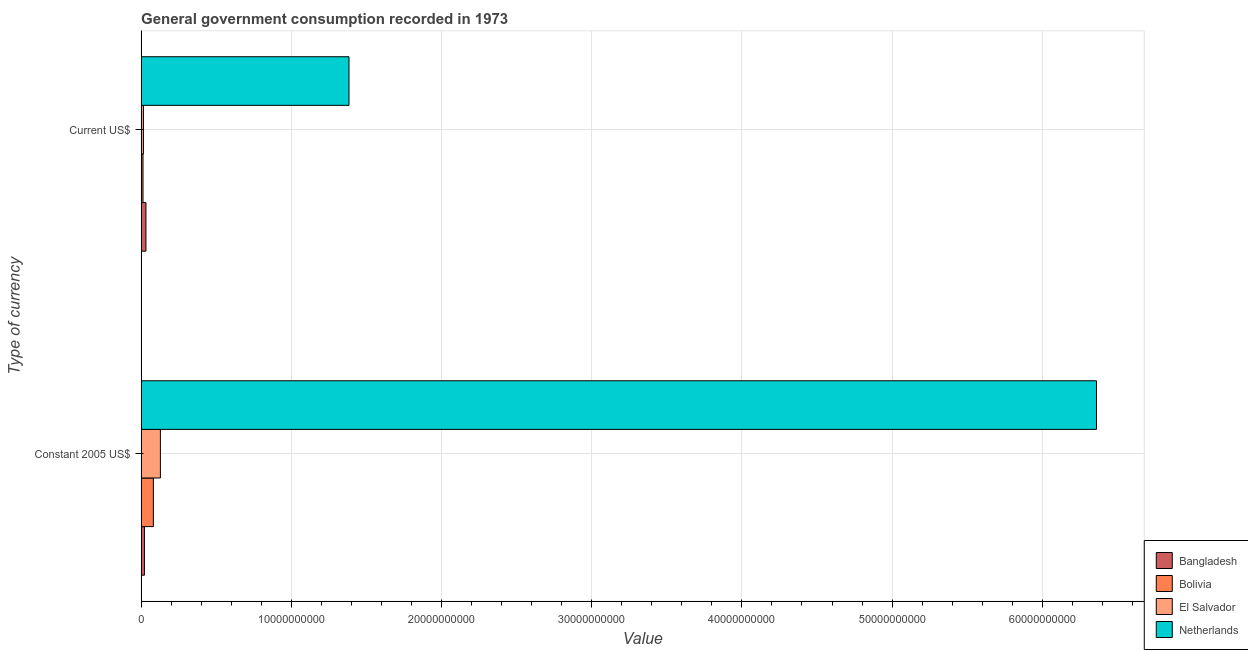How many groups of bars are there?
Ensure brevity in your answer.  2. Are the number of bars per tick equal to the number of legend labels?
Provide a short and direct response. Yes. How many bars are there on the 1st tick from the top?
Keep it short and to the point. 4. How many bars are there on the 1st tick from the bottom?
Offer a very short reply. 4. What is the label of the 2nd group of bars from the top?
Your response must be concise. Constant 2005 US$. What is the value consumed in constant 2005 us$ in Bolivia?
Make the answer very short. 8.13e+08. Across all countries, what is the maximum value consumed in constant 2005 us$?
Provide a short and direct response. 6.36e+1. Across all countries, what is the minimum value consumed in current us$?
Ensure brevity in your answer.  1.24e+08. In which country was the value consumed in constant 2005 us$ minimum?
Provide a short and direct response. Bangladesh. What is the total value consumed in constant 2005 us$ in the graph?
Make the answer very short. 6.59e+1. What is the difference between the value consumed in current us$ in Bolivia and that in Bangladesh?
Offer a terse response. -1.94e+08. What is the difference between the value consumed in current us$ in Bangladesh and the value consumed in constant 2005 us$ in Bolivia?
Offer a very short reply. -4.95e+08. What is the average value consumed in current us$ per country?
Offer a terse response. 3.61e+09. What is the difference between the value consumed in current us$ and value consumed in constant 2005 us$ in Netherlands?
Your answer should be compact. -4.98e+1. What is the ratio of the value consumed in constant 2005 us$ in Bangladesh to that in Bolivia?
Offer a terse response. 0.27. What does the 2nd bar from the top in Current US$ represents?
Offer a terse response. El Salvador. What does the 4th bar from the bottom in Constant 2005 US$ represents?
Ensure brevity in your answer.  Netherlands. What is the difference between two consecutive major ticks on the X-axis?
Offer a terse response. 1.00e+1. Are the values on the major ticks of X-axis written in scientific E-notation?
Make the answer very short. No. How many legend labels are there?
Your answer should be very brief. 4. What is the title of the graph?
Provide a short and direct response. General government consumption recorded in 1973. What is the label or title of the X-axis?
Keep it short and to the point. Value. What is the label or title of the Y-axis?
Your answer should be compact. Type of currency. What is the Value of Bangladesh in Constant 2005 US$?
Make the answer very short. 2.20e+08. What is the Value in Bolivia in Constant 2005 US$?
Ensure brevity in your answer.  8.13e+08. What is the Value in El Salvador in Constant 2005 US$?
Offer a very short reply. 1.28e+09. What is the Value of Netherlands in Constant 2005 US$?
Offer a very short reply. 6.36e+1. What is the Value of Bangladesh in Current US$?
Make the answer very short. 3.19e+08. What is the Value in Bolivia in Current US$?
Your answer should be very brief. 1.24e+08. What is the Value in El Salvador in Current US$?
Offer a very short reply. 1.51e+08. What is the Value in Netherlands in Current US$?
Offer a terse response. 1.38e+1. Across all Type of currency, what is the maximum Value in Bangladesh?
Offer a terse response. 3.19e+08. Across all Type of currency, what is the maximum Value of Bolivia?
Offer a very short reply. 8.13e+08. Across all Type of currency, what is the maximum Value of El Salvador?
Your answer should be compact. 1.28e+09. Across all Type of currency, what is the maximum Value in Netherlands?
Your answer should be very brief. 6.36e+1. Across all Type of currency, what is the minimum Value in Bangladesh?
Ensure brevity in your answer.  2.20e+08. Across all Type of currency, what is the minimum Value of Bolivia?
Your response must be concise. 1.24e+08. Across all Type of currency, what is the minimum Value in El Salvador?
Give a very brief answer. 1.51e+08. Across all Type of currency, what is the minimum Value in Netherlands?
Your answer should be compact. 1.38e+1. What is the total Value in Bangladesh in the graph?
Offer a very short reply. 5.39e+08. What is the total Value of Bolivia in the graph?
Keep it short and to the point. 9.38e+08. What is the total Value of El Salvador in the graph?
Your answer should be compact. 1.43e+09. What is the total Value in Netherlands in the graph?
Give a very brief answer. 7.74e+1. What is the difference between the Value of Bangladesh in Constant 2005 US$ and that in Current US$?
Offer a terse response. -9.83e+07. What is the difference between the Value of Bolivia in Constant 2005 US$ and that in Current US$?
Offer a terse response. 6.89e+08. What is the difference between the Value in El Salvador in Constant 2005 US$ and that in Current US$?
Give a very brief answer. 1.13e+09. What is the difference between the Value in Netherlands in Constant 2005 US$ and that in Current US$?
Keep it short and to the point. 4.98e+1. What is the difference between the Value of Bangladesh in Constant 2005 US$ and the Value of Bolivia in Current US$?
Offer a terse response. 9.58e+07. What is the difference between the Value in Bangladesh in Constant 2005 US$ and the Value in El Salvador in Current US$?
Offer a very short reply. 6.91e+07. What is the difference between the Value of Bangladesh in Constant 2005 US$ and the Value of Netherlands in Current US$?
Give a very brief answer. -1.36e+1. What is the difference between the Value of Bolivia in Constant 2005 US$ and the Value of El Salvador in Current US$?
Give a very brief answer. 6.62e+08. What is the difference between the Value in Bolivia in Constant 2005 US$ and the Value in Netherlands in Current US$?
Offer a very short reply. -1.30e+1. What is the difference between the Value in El Salvador in Constant 2005 US$ and the Value in Netherlands in Current US$?
Keep it short and to the point. -1.26e+1. What is the average Value in Bangladesh per Type of currency?
Give a very brief answer. 2.69e+08. What is the average Value of Bolivia per Type of currency?
Your response must be concise. 4.69e+08. What is the average Value in El Salvador per Type of currency?
Provide a succinct answer. 7.16e+08. What is the average Value of Netherlands per Type of currency?
Keep it short and to the point. 3.87e+1. What is the difference between the Value in Bangladesh and Value in Bolivia in Constant 2005 US$?
Give a very brief answer. -5.93e+08. What is the difference between the Value in Bangladesh and Value in El Salvador in Constant 2005 US$?
Your response must be concise. -1.06e+09. What is the difference between the Value in Bangladesh and Value in Netherlands in Constant 2005 US$?
Give a very brief answer. -6.34e+1. What is the difference between the Value in Bolivia and Value in El Salvador in Constant 2005 US$?
Make the answer very short. -4.69e+08. What is the difference between the Value of Bolivia and Value of Netherlands in Constant 2005 US$?
Provide a succinct answer. -6.28e+1. What is the difference between the Value in El Salvador and Value in Netherlands in Constant 2005 US$?
Your response must be concise. -6.23e+1. What is the difference between the Value of Bangladesh and Value of Bolivia in Current US$?
Ensure brevity in your answer.  1.94e+08. What is the difference between the Value in Bangladesh and Value in El Salvador in Current US$?
Make the answer very short. 1.67e+08. What is the difference between the Value of Bangladesh and Value of Netherlands in Current US$?
Your response must be concise. -1.35e+1. What is the difference between the Value in Bolivia and Value in El Salvador in Current US$?
Ensure brevity in your answer.  -2.66e+07. What is the difference between the Value in Bolivia and Value in Netherlands in Current US$?
Keep it short and to the point. -1.37e+1. What is the difference between the Value of El Salvador and Value of Netherlands in Current US$?
Offer a very short reply. -1.37e+1. What is the ratio of the Value in Bangladesh in Constant 2005 US$ to that in Current US$?
Your answer should be compact. 0.69. What is the ratio of the Value of Bolivia in Constant 2005 US$ to that in Current US$?
Your response must be concise. 6.53. What is the ratio of the Value in El Salvador in Constant 2005 US$ to that in Current US$?
Provide a succinct answer. 8.48. What is the ratio of the Value of Netherlands in Constant 2005 US$ to that in Current US$?
Your response must be concise. 4.6. What is the difference between the highest and the second highest Value of Bangladesh?
Give a very brief answer. 9.83e+07. What is the difference between the highest and the second highest Value of Bolivia?
Your answer should be very brief. 6.89e+08. What is the difference between the highest and the second highest Value of El Salvador?
Ensure brevity in your answer.  1.13e+09. What is the difference between the highest and the second highest Value in Netherlands?
Ensure brevity in your answer.  4.98e+1. What is the difference between the highest and the lowest Value of Bangladesh?
Your response must be concise. 9.83e+07. What is the difference between the highest and the lowest Value in Bolivia?
Give a very brief answer. 6.89e+08. What is the difference between the highest and the lowest Value in El Salvador?
Keep it short and to the point. 1.13e+09. What is the difference between the highest and the lowest Value of Netherlands?
Ensure brevity in your answer.  4.98e+1. 